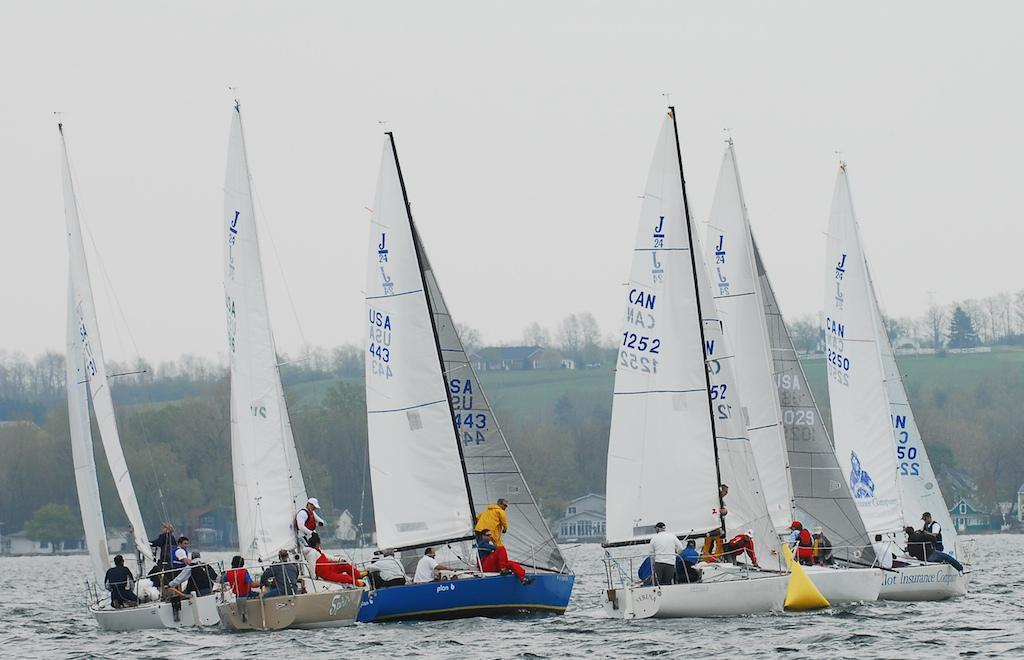<image>
Write a terse but informative summary of the picture. A group of sailboats compete at a regatta, and the blue sailboat is from the USA and numbered 443 on the sail. 